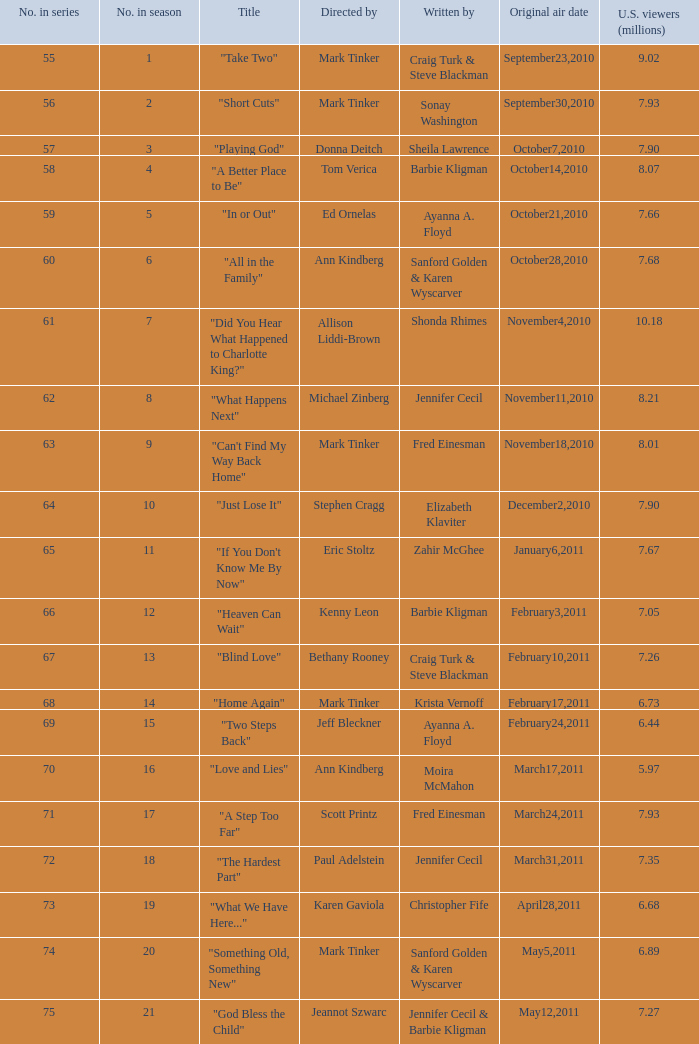What is the earliest listed episode of the season? 1.0. Give me the full table as a dictionary. {'header': ['No. in series', 'No. in season', 'Title', 'Directed by', 'Written by', 'Original air date', 'U.S. viewers (millions)'], 'rows': [['55', '1', '"Take Two"', 'Mark Tinker', 'Craig Turk & Steve Blackman', 'September23,2010', '9.02'], ['56', '2', '"Short Cuts"', 'Mark Tinker', 'Sonay Washington', 'September30,2010', '7.93'], ['57', '3', '"Playing God"', 'Donna Deitch', 'Sheila Lawrence', 'October7,2010', '7.90'], ['58', '4', '"A Better Place to Be"', 'Tom Verica', 'Barbie Kligman', 'October14,2010', '8.07'], ['59', '5', '"In or Out"', 'Ed Ornelas', 'Ayanna A. Floyd', 'October21,2010', '7.66'], ['60', '6', '"All in the Family"', 'Ann Kindberg', 'Sanford Golden & Karen Wyscarver', 'October28,2010', '7.68'], ['61', '7', '"Did You Hear What Happened to Charlotte King?"', 'Allison Liddi-Brown', 'Shonda Rhimes', 'November4,2010', '10.18'], ['62', '8', '"What Happens Next"', 'Michael Zinberg', 'Jennifer Cecil', 'November11,2010', '8.21'], ['63', '9', '"Can\'t Find My Way Back Home"', 'Mark Tinker', 'Fred Einesman', 'November18,2010', '8.01'], ['64', '10', '"Just Lose It"', 'Stephen Cragg', 'Elizabeth Klaviter', 'December2,2010', '7.90'], ['65', '11', '"If You Don\'t Know Me By Now"', 'Eric Stoltz', 'Zahir McGhee', 'January6,2011', '7.67'], ['66', '12', '"Heaven Can Wait"', 'Kenny Leon', 'Barbie Kligman', 'February3,2011', '7.05'], ['67', '13', '"Blind Love"', 'Bethany Rooney', 'Craig Turk & Steve Blackman', 'February10,2011', '7.26'], ['68', '14', '"Home Again"', 'Mark Tinker', 'Krista Vernoff', 'February17,2011', '6.73'], ['69', '15', '"Two Steps Back"', 'Jeff Bleckner', 'Ayanna A. Floyd', 'February24,2011', '6.44'], ['70', '16', '"Love and Lies"', 'Ann Kindberg', 'Moira McMahon', 'March17,2011', '5.97'], ['71', '17', '"A Step Too Far"', 'Scott Printz', 'Fred Einesman', 'March24,2011', '7.93'], ['72', '18', '"The Hardest Part"', 'Paul Adelstein', 'Jennifer Cecil', 'March31,2011', '7.35'], ['73', '19', '"What We Have Here..."', 'Karen Gaviola', 'Christopher Fife', 'April28,2011', '6.68'], ['74', '20', '"Something Old, Something New"', 'Mark Tinker', 'Sanford Golden & Karen Wyscarver', 'May5,2011', '6.89'], ['75', '21', '"God Bless the Child"', 'Jeannot Szwarc', 'Jennifer Cecil & Barbie Kligman', 'May12,2011', '7.27']]} 